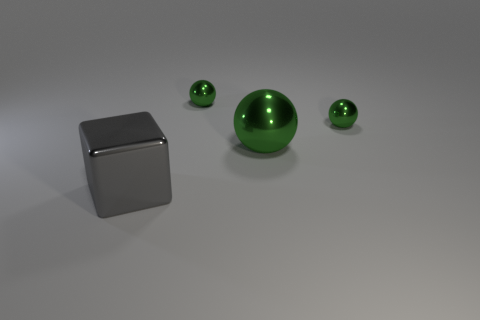Add 1 large green rubber cylinders. How many objects exist? 5 Subtract all spheres. How many objects are left? 1 Subtract 0 red cylinders. How many objects are left? 4 Subtract all big purple things. Subtract all spheres. How many objects are left? 1 Add 3 gray objects. How many gray objects are left? 4 Add 3 tiny gray spheres. How many tiny gray spheres exist? 3 